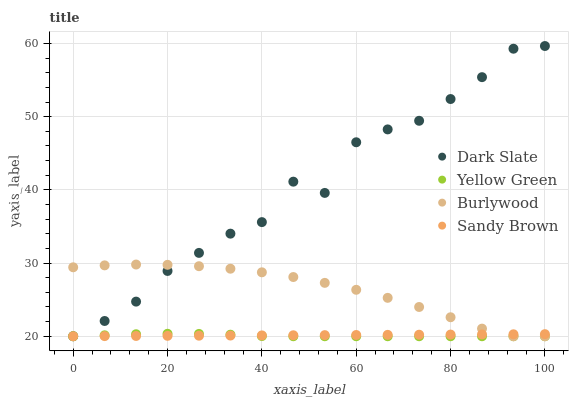Does Yellow Green have the minimum area under the curve?
Answer yes or no. Yes. Does Dark Slate have the maximum area under the curve?
Answer yes or no. Yes. Does Sandy Brown have the minimum area under the curve?
Answer yes or no. No. Does Sandy Brown have the maximum area under the curve?
Answer yes or no. No. Is Sandy Brown the smoothest?
Answer yes or no. Yes. Is Dark Slate the roughest?
Answer yes or no. Yes. Is Dark Slate the smoothest?
Answer yes or no. No. Is Sandy Brown the roughest?
Answer yes or no. No. Does Burlywood have the lowest value?
Answer yes or no. Yes. Does Dark Slate have the highest value?
Answer yes or no. Yes. Does Sandy Brown have the highest value?
Answer yes or no. No. Does Burlywood intersect Sandy Brown?
Answer yes or no. Yes. Is Burlywood less than Sandy Brown?
Answer yes or no. No. Is Burlywood greater than Sandy Brown?
Answer yes or no. No. 